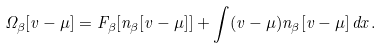Convert formula to latex. <formula><loc_0><loc_0><loc_500><loc_500>\Omega _ { \beta } [ v - \mu ] = F _ { \beta } [ n _ { \beta } [ v - \mu ] ] + \int ( v - \mu ) n _ { \beta } [ v - \mu ] \, d x .</formula> 